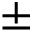<formula> <loc_0><loc_0><loc_500><loc_500>\pm</formula> 